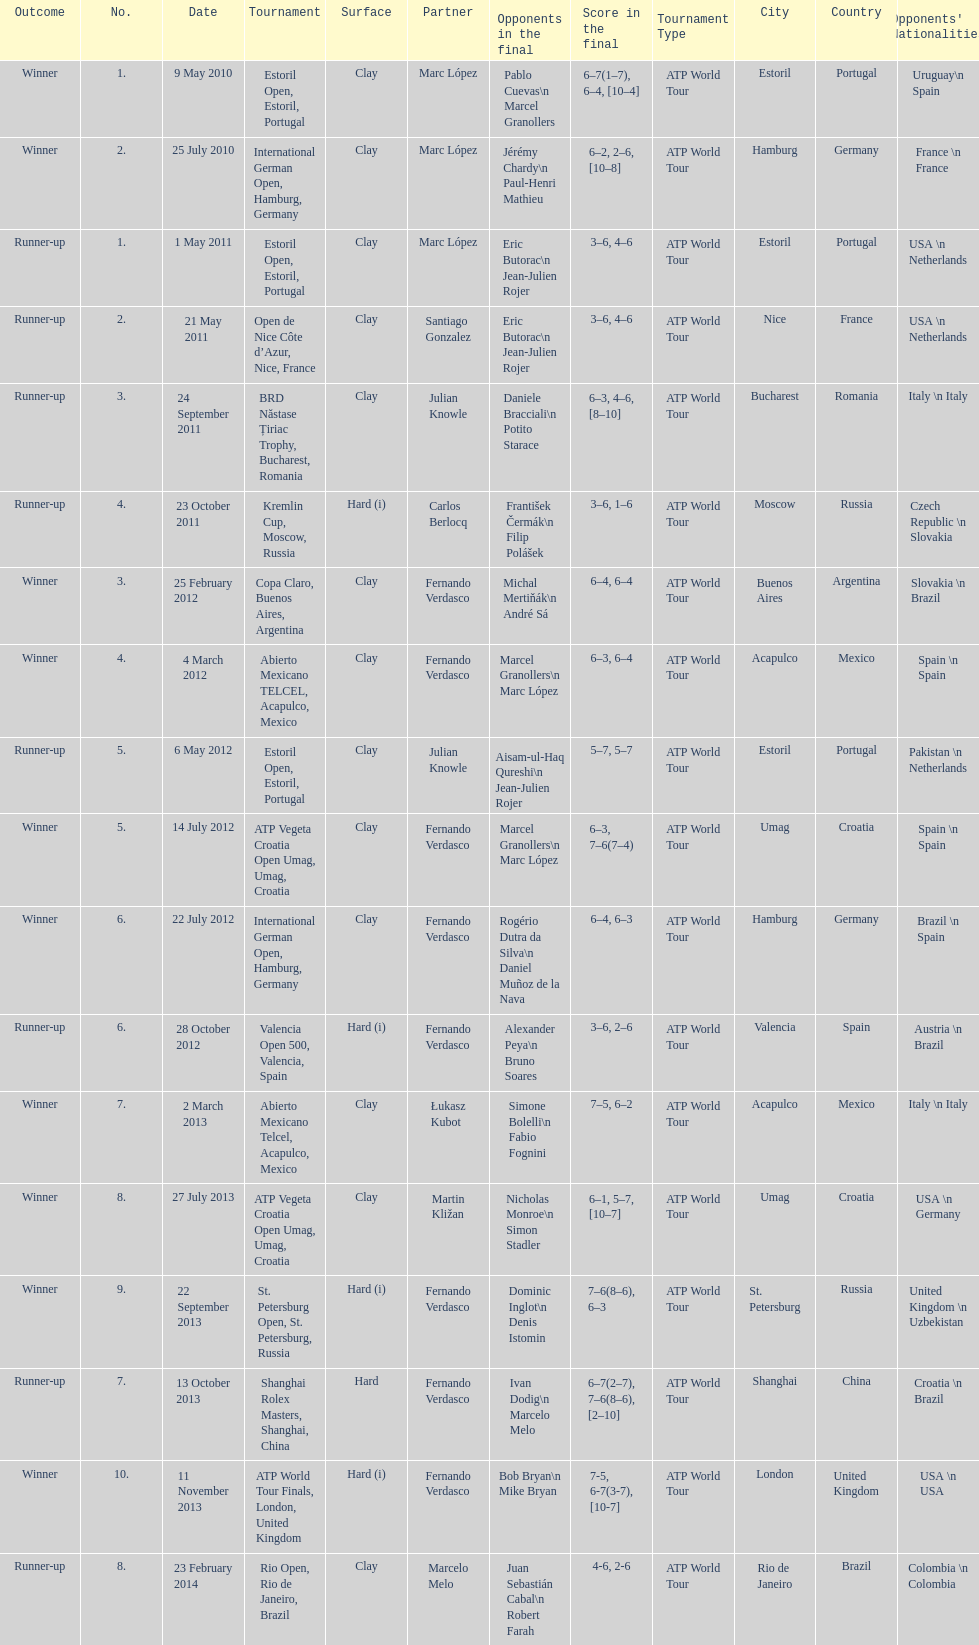Help me parse the entirety of this table. {'header': ['Outcome', 'No.', 'Date', 'Tournament', 'Surface', 'Partner', 'Opponents in the final', 'Score in the final', 'Tournament Type', 'City', 'Country', "Opponents' Nationalities"], 'rows': [['Winner', '1.', '9 May 2010', 'Estoril Open, Estoril, Portugal', 'Clay', 'Marc López', 'Pablo Cuevas\\n Marcel Granollers', '6–7(1–7), 6–4, [10–4]', 'ATP World Tour', 'Estoril', 'Portugal', 'Uruguay\\n Spain'], ['Winner', '2.', '25 July 2010', 'International German Open, Hamburg, Germany', 'Clay', 'Marc López', 'Jérémy Chardy\\n Paul-Henri Mathieu', '6–2, 2–6, [10–8]', 'ATP World Tour', 'Hamburg', 'Germany', 'France \\n France'], ['Runner-up', '1.', '1 May 2011', 'Estoril Open, Estoril, Portugal', 'Clay', 'Marc López', 'Eric Butorac\\n Jean-Julien Rojer', '3–6, 4–6', 'ATP World Tour', 'Estoril', 'Portugal', 'USA \\n Netherlands'], ['Runner-up', '2.', '21 May 2011', 'Open de Nice Côte d’Azur, Nice, France', 'Clay', 'Santiago Gonzalez', 'Eric Butorac\\n Jean-Julien Rojer', '3–6, 4–6', 'ATP World Tour', 'Nice', 'France', 'USA \\n Netherlands'], ['Runner-up', '3.', '24 September 2011', 'BRD Năstase Țiriac Trophy, Bucharest, Romania', 'Clay', 'Julian Knowle', 'Daniele Bracciali\\n Potito Starace', '6–3, 4–6, [8–10]', 'ATP World Tour', 'Bucharest', 'Romania', 'Italy \\n Italy'], ['Runner-up', '4.', '23 October 2011', 'Kremlin Cup, Moscow, Russia', 'Hard (i)', 'Carlos Berlocq', 'František Čermák\\n Filip Polášek', '3–6, 1–6', 'ATP World Tour', 'Moscow', 'Russia', 'Czech Republic \\n Slovakia'], ['Winner', '3.', '25 February 2012', 'Copa Claro, Buenos Aires, Argentina', 'Clay', 'Fernando Verdasco', 'Michal Mertiňák\\n André Sá', '6–4, 6–4', 'ATP World Tour', 'Buenos Aires', 'Argentina', 'Slovakia \\n Brazil'], ['Winner', '4.', '4 March 2012', 'Abierto Mexicano TELCEL, Acapulco, Mexico', 'Clay', 'Fernando Verdasco', 'Marcel Granollers\\n Marc López', '6–3, 6–4', 'ATP World Tour', 'Acapulco', 'Mexico', 'Spain \\n Spain'], ['Runner-up', '5.', '6 May 2012', 'Estoril Open, Estoril, Portugal', 'Clay', 'Julian Knowle', 'Aisam-ul-Haq Qureshi\\n Jean-Julien Rojer', '5–7, 5–7', 'ATP World Tour', 'Estoril', 'Portugal', 'Pakistan \\n Netherlands'], ['Winner', '5.', '14 July 2012', 'ATP Vegeta Croatia Open Umag, Umag, Croatia', 'Clay', 'Fernando Verdasco', 'Marcel Granollers\\n Marc López', '6–3, 7–6(7–4)', 'ATP World Tour', 'Umag', 'Croatia', 'Spain \\n Spain'], ['Winner', '6.', '22 July 2012', 'International German Open, Hamburg, Germany', 'Clay', 'Fernando Verdasco', 'Rogério Dutra da Silva\\n Daniel Muñoz de la Nava', '6–4, 6–3', 'ATP World Tour', 'Hamburg', 'Germany', 'Brazil \\n Spain'], ['Runner-up', '6.', '28 October 2012', 'Valencia Open 500, Valencia, Spain', 'Hard (i)', 'Fernando Verdasco', 'Alexander Peya\\n Bruno Soares', '3–6, 2–6', 'ATP World Tour', 'Valencia', 'Spain', 'Austria \\n Brazil'], ['Winner', '7.', '2 March 2013', 'Abierto Mexicano Telcel, Acapulco, Mexico', 'Clay', 'Łukasz Kubot', 'Simone Bolelli\\n Fabio Fognini', '7–5, 6–2', 'ATP World Tour', 'Acapulco', 'Mexico', 'Italy \\n Italy'], ['Winner', '8.', '27 July 2013', 'ATP Vegeta Croatia Open Umag, Umag, Croatia', 'Clay', 'Martin Kližan', 'Nicholas Monroe\\n Simon Stadler', '6–1, 5–7, [10–7]', 'ATP World Tour', 'Umag', 'Croatia', 'USA \\n Germany'], ['Winner', '9.', '22 September 2013', 'St. Petersburg Open, St. Petersburg, Russia', 'Hard (i)', 'Fernando Verdasco', 'Dominic Inglot\\n Denis Istomin', '7–6(8–6), 6–3', 'ATP World Tour', 'St. Petersburg', 'Russia', 'United Kingdom \\n Uzbekistan'], ['Runner-up', '7.', '13 October 2013', 'Shanghai Rolex Masters, Shanghai, China', 'Hard', 'Fernando Verdasco', 'Ivan Dodig\\n Marcelo Melo', '6–7(2–7), 7–6(8–6), [2–10]', 'ATP World Tour', 'Shanghai', 'China', 'Croatia \\n Brazil'], ['Winner', '10.', '11 November 2013', 'ATP World Tour Finals, London, United Kingdom', 'Hard (i)', 'Fernando Verdasco', 'Bob Bryan\\n Mike Bryan', '7-5, 6-7(3-7), [10-7]', 'ATP World Tour', 'London', 'United Kingdom', 'USA \\n USA'], ['Runner-up', '8.', '23 February 2014', 'Rio Open, Rio de Janeiro, Brazil', 'Clay', 'Marcelo Melo', 'Juan Sebastián Cabal\\n Robert Farah', '4-6, 2-6', 'ATP World Tour', 'Rio de Janeiro', 'Brazil', 'Colombia \\n Colombia']]} Which event holds the biggest number? ATP World Tour Finals. 